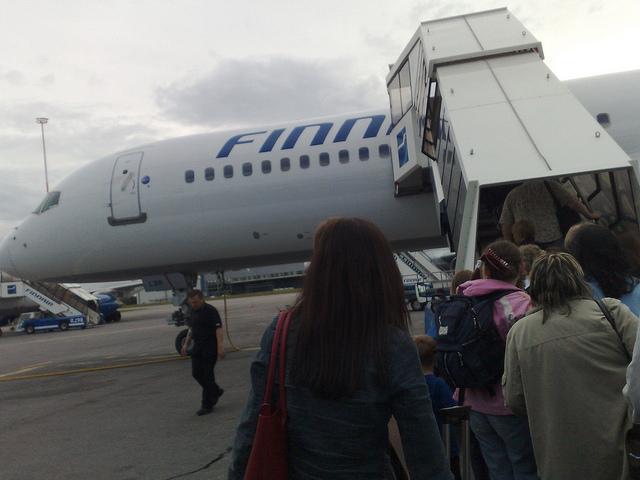How many people are there?
Give a very brief answer. 6. How many surfboards are there?
Give a very brief answer. 0. 